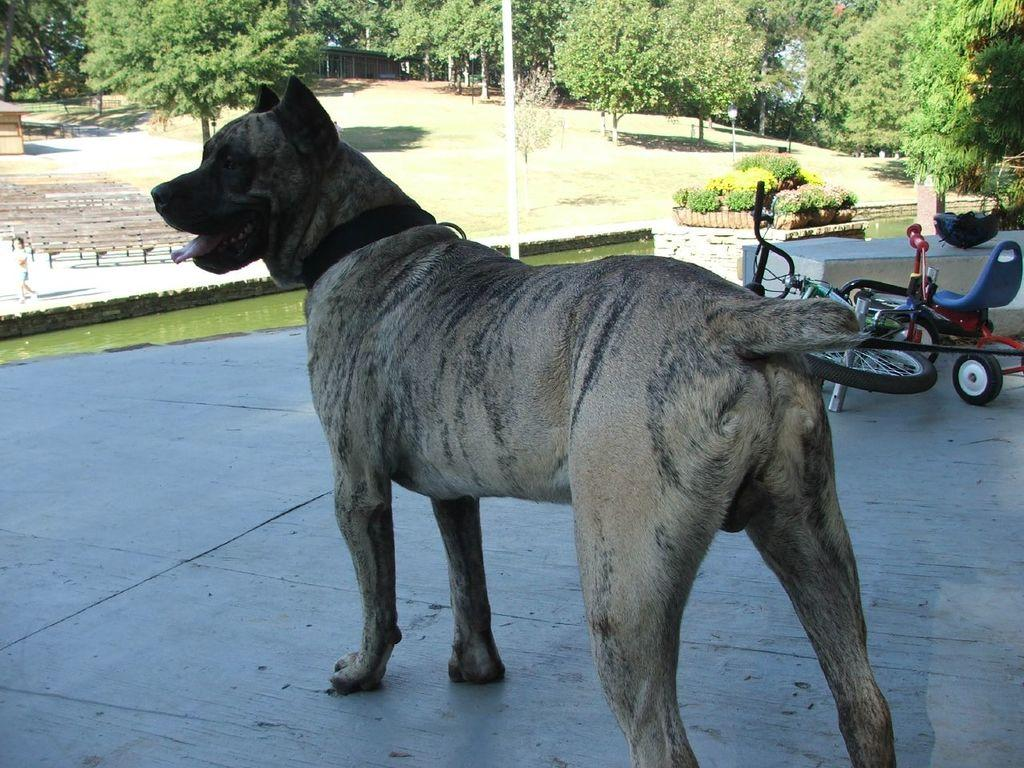What is the main subject in the center of the image? There is a dog in the center of the image. What can be seen in the background of the image? There are trees, plants, poles, water, and a bicycle visible in the background. Can you describe the girl on the left side of the image? There is a small girl on the left side of the image. What type of star can be seen shining brightly in the image? There is no star visible in the image. Can you describe the hen and duck that are playing together in the image? There are no hen or duck present in the image. 